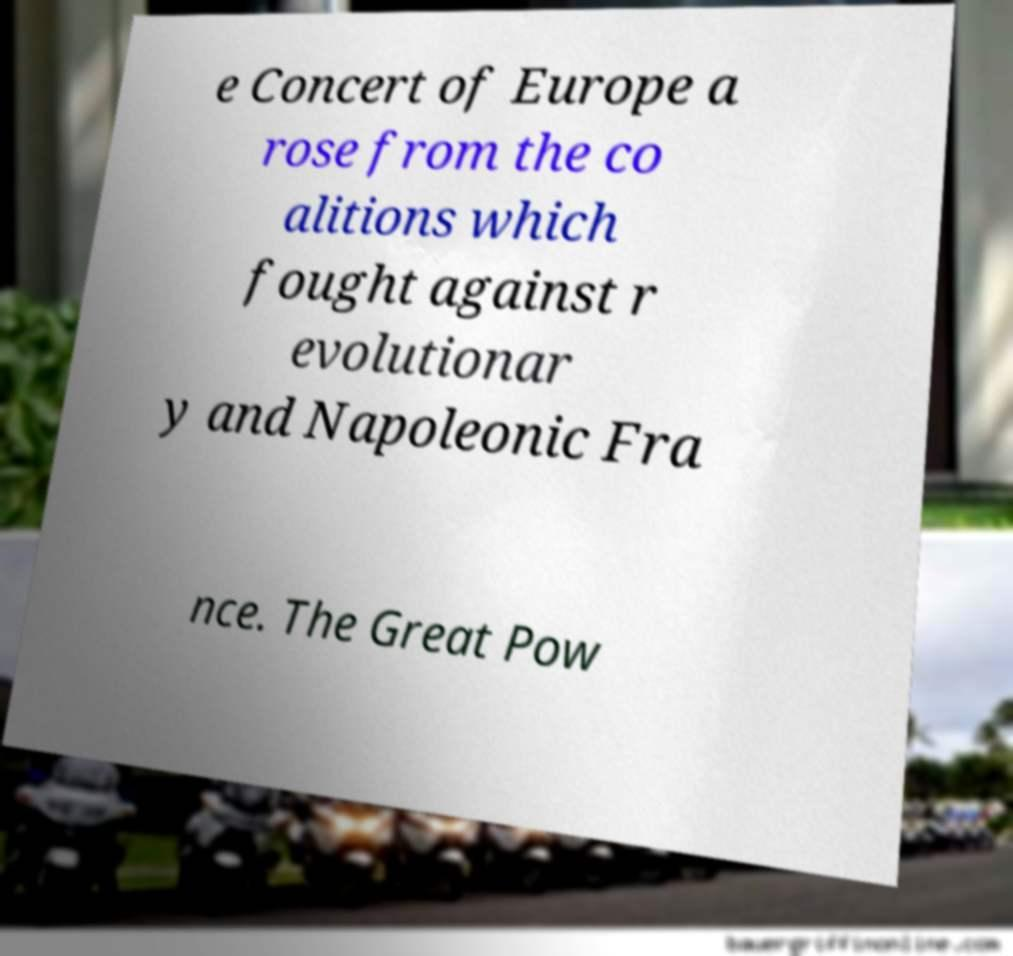What messages or text are displayed in this image? I need them in a readable, typed format. e Concert of Europe a rose from the co alitions which fought against r evolutionar y and Napoleonic Fra nce. The Great Pow 